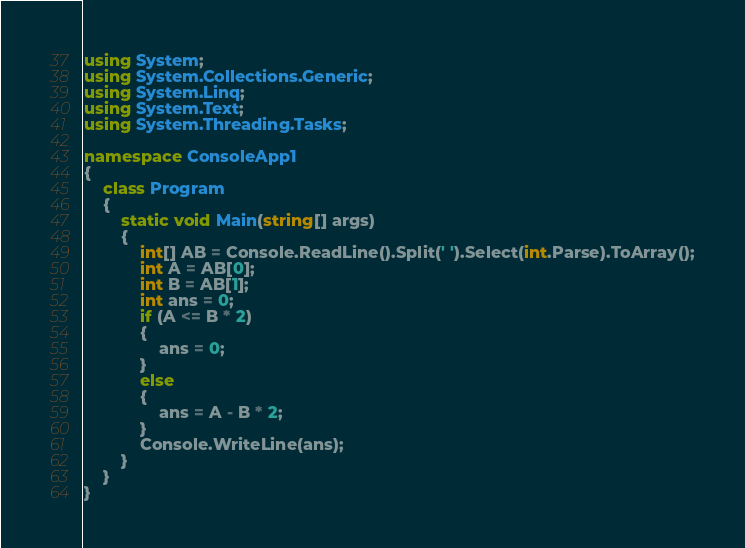<code> <loc_0><loc_0><loc_500><loc_500><_C#_>using System;
using System.Collections.Generic;
using System.Linq;
using System.Text;
using System.Threading.Tasks;

namespace ConsoleApp1
{
    class Program
    {
        static void Main(string[] args)
        {
            int[] AB = Console.ReadLine().Split(' ').Select(int.Parse).ToArray();
            int A = AB[0];
            int B = AB[1];
            int ans = 0;
            if (A <= B * 2)
            {
                ans = 0;
            }
            else
            {
                ans = A - B * 2;
            }
            Console.WriteLine(ans);
        }
    }
}
</code> 